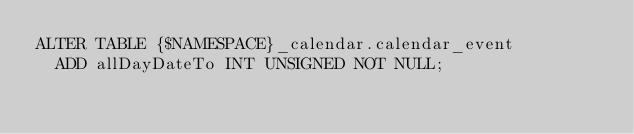Convert code to text. <code><loc_0><loc_0><loc_500><loc_500><_SQL_>ALTER TABLE {$NAMESPACE}_calendar.calendar_event
  ADD allDayDateTo INT UNSIGNED NOT NULL;
</code> 